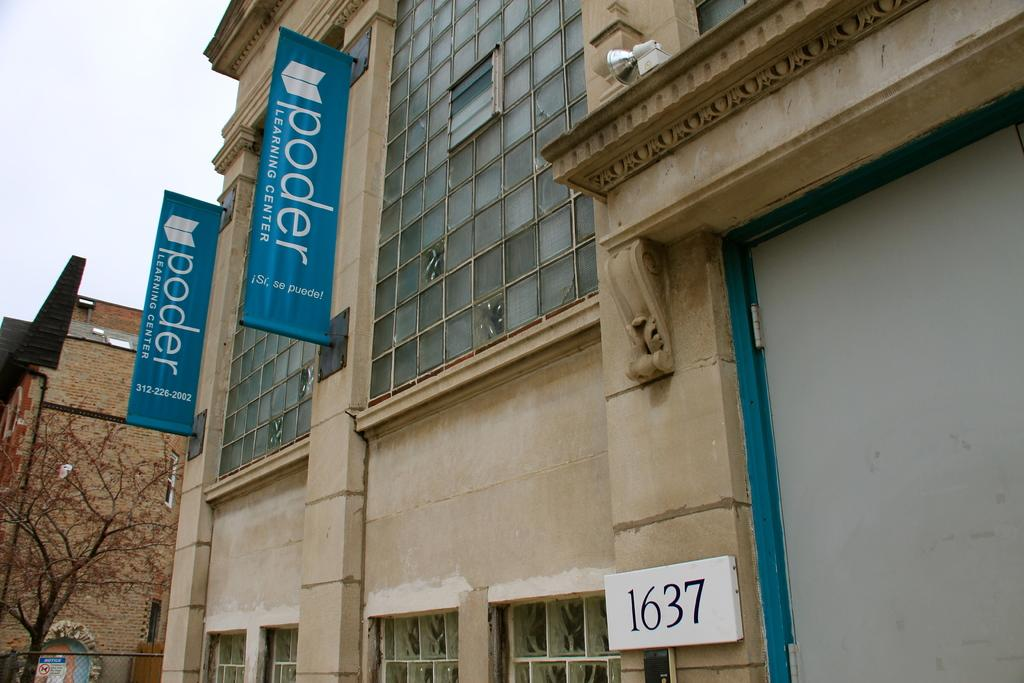What type of structures can be seen in the image? There are buildings in the image. Are there any specific features inside the buildings? Yes, there are posters in one of the buildings. What type of walls are present in the image? There are glass walls in the image. What can be seen on the left side of the image? There is a tree on the left side of the image. What type of letters are being handed out during the protest in the image? There is no protest or letters present in the image; it only features buildings, posters, glass walls, and a tree. 